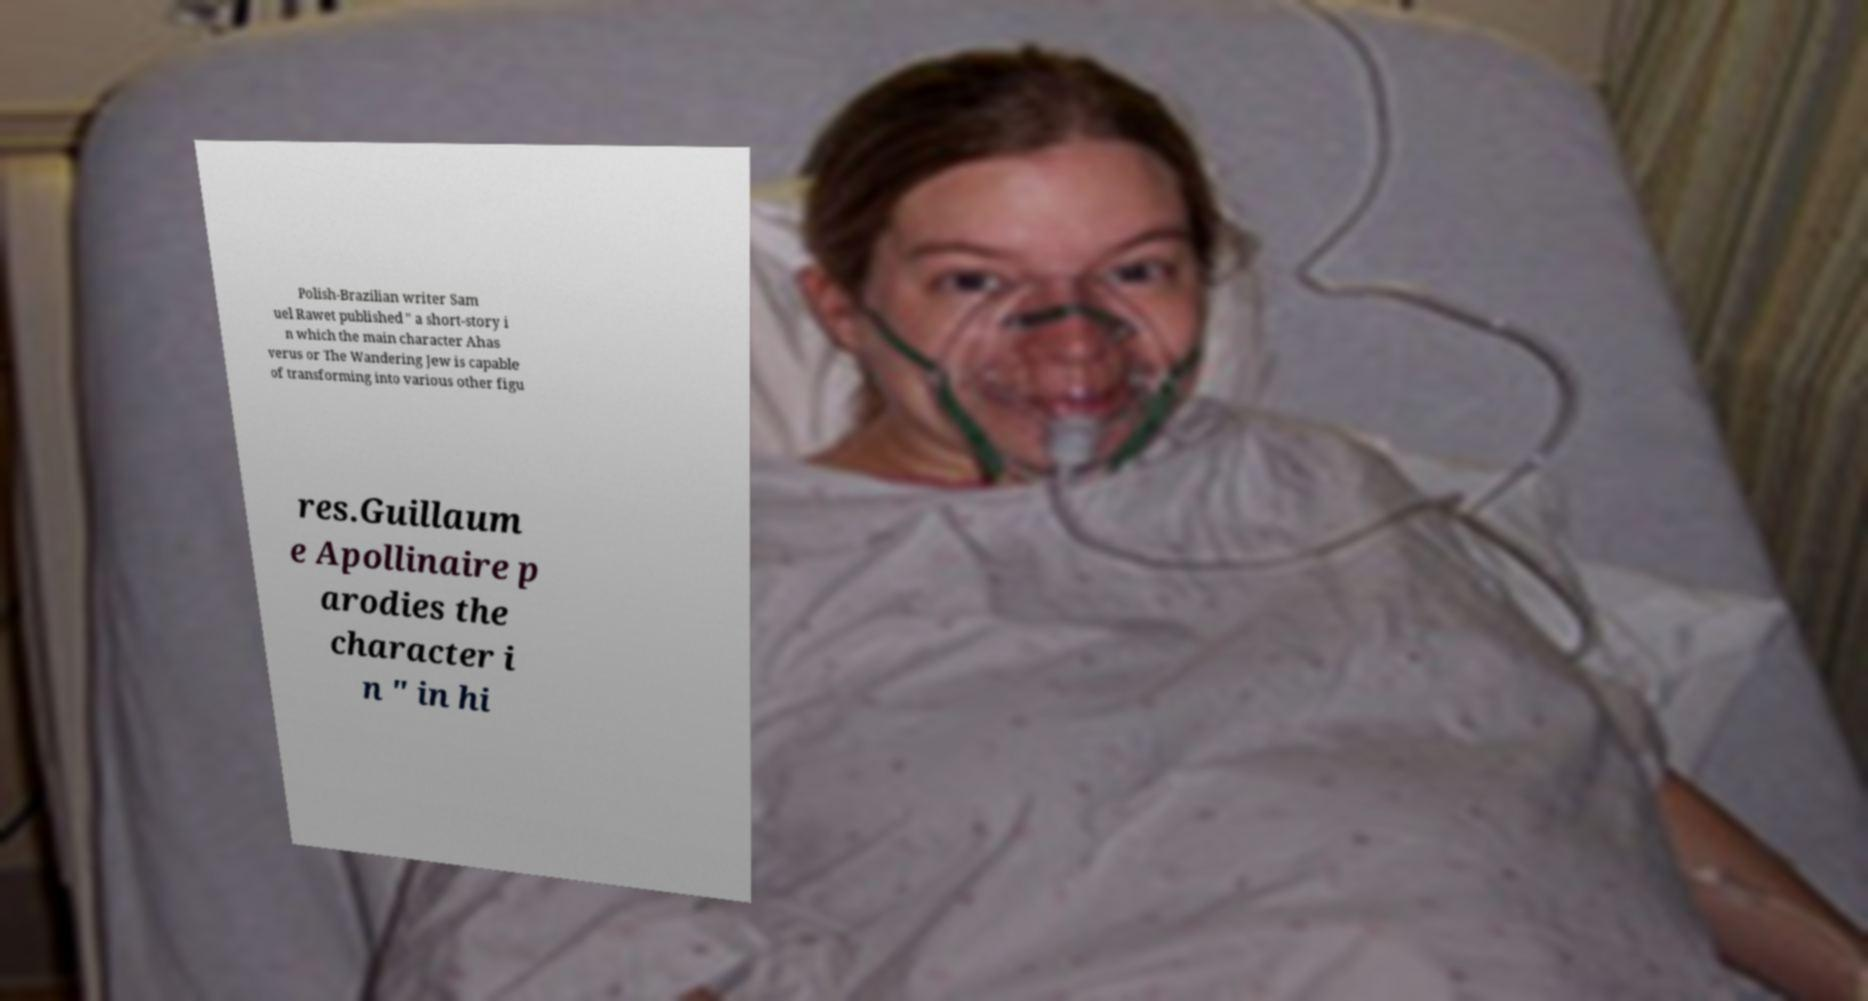What messages or text are displayed in this image? I need them in a readable, typed format. Polish-Brazilian writer Sam uel Rawet published " a short-story i n which the main character Ahas verus or The Wandering Jew is capable of transforming into various other figu res.Guillaum e Apollinaire p arodies the character i n " in hi 